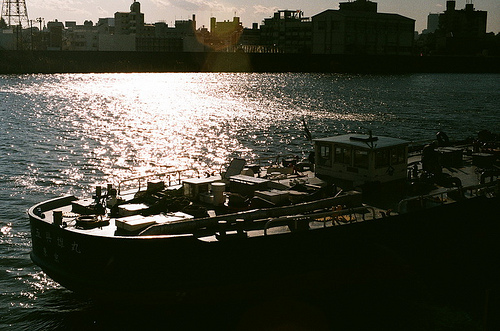Can you describe the activity happening on the boat? The boat has several people aboard who seem to be involved in either loading or unloading items, suggesting some commercial or logistic activity. 